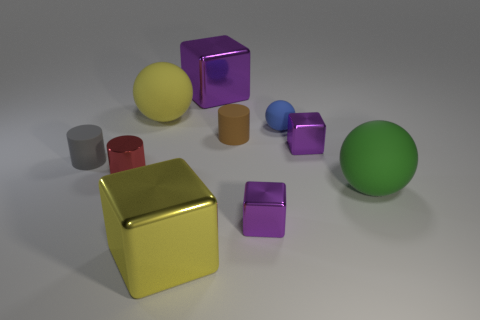Are there the same number of small cylinders that are behind the small blue matte object and small cyan matte blocks?
Offer a very short reply. Yes. What number of large matte balls are in front of the big purple cube?
Your response must be concise. 2. The green rubber ball has what size?
Make the answer very short. Large. What color is the other cylinder that is the same material as the gray cylinder?
Your answer should be very brief. Brown. What number of green matte things are the same size as the blue thing?
Your response must be concise. 0. Is the ball that is left of the big yellow shiny object made of the same material as the brown cylinder?
Provide a succinct answer. Yes. Is the number of large balls on the right side of the yellow shiny object less than the number of big cyan balls?
Provide a short and direct response. No. What is the shape of the large yellow object left of the large yellow metal object?
Make the answer very short. Sphere. The gray rubber thing that is the same size as the blue rubber sphere is what shape?
Make the answer very short. Cylinder. Is there a brown thing of the same shape as the green rubber thing?
Give a very brief answer. No. 